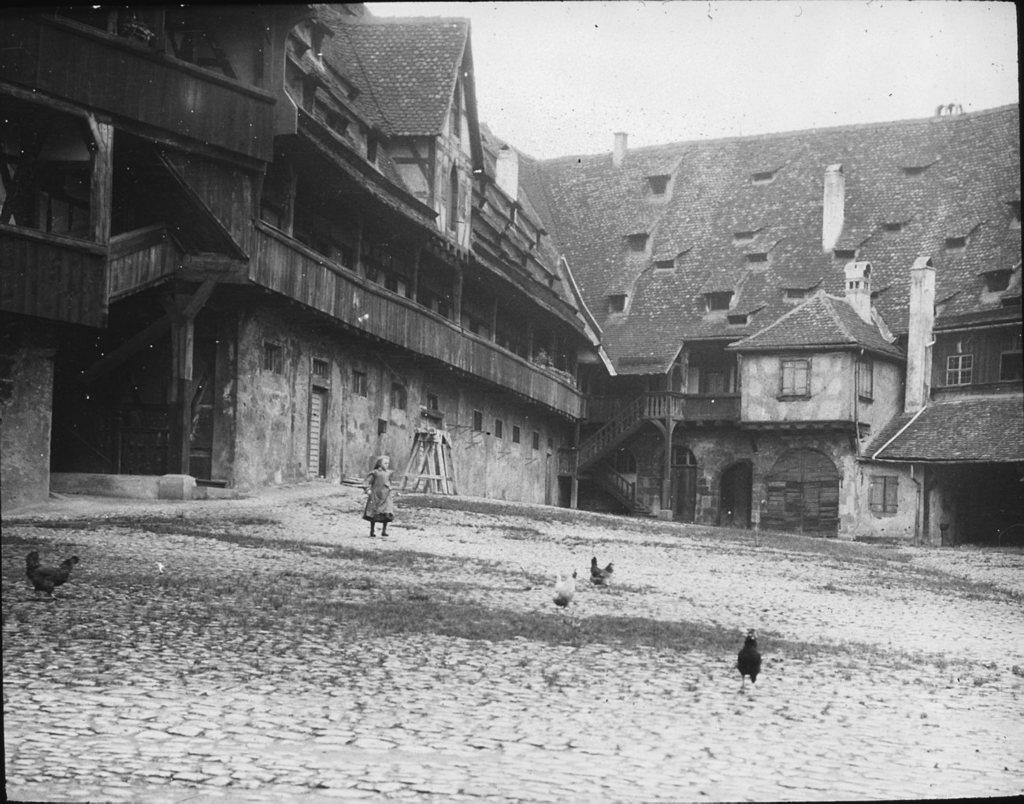What is located in the center of the image? There are birds in the center of the image. What is the girl in the image doing? The girl is walking in the image. What can be seen in the background of the image? There are buildings in the background of the image. What is the girl's opinion about the birds in the image? There is no information about the girl's opinion in the image, as it only shows her walking and the presence of birds. How many parents are visible in the image? There are no parents present in the image; it features birds and a girl walking. 